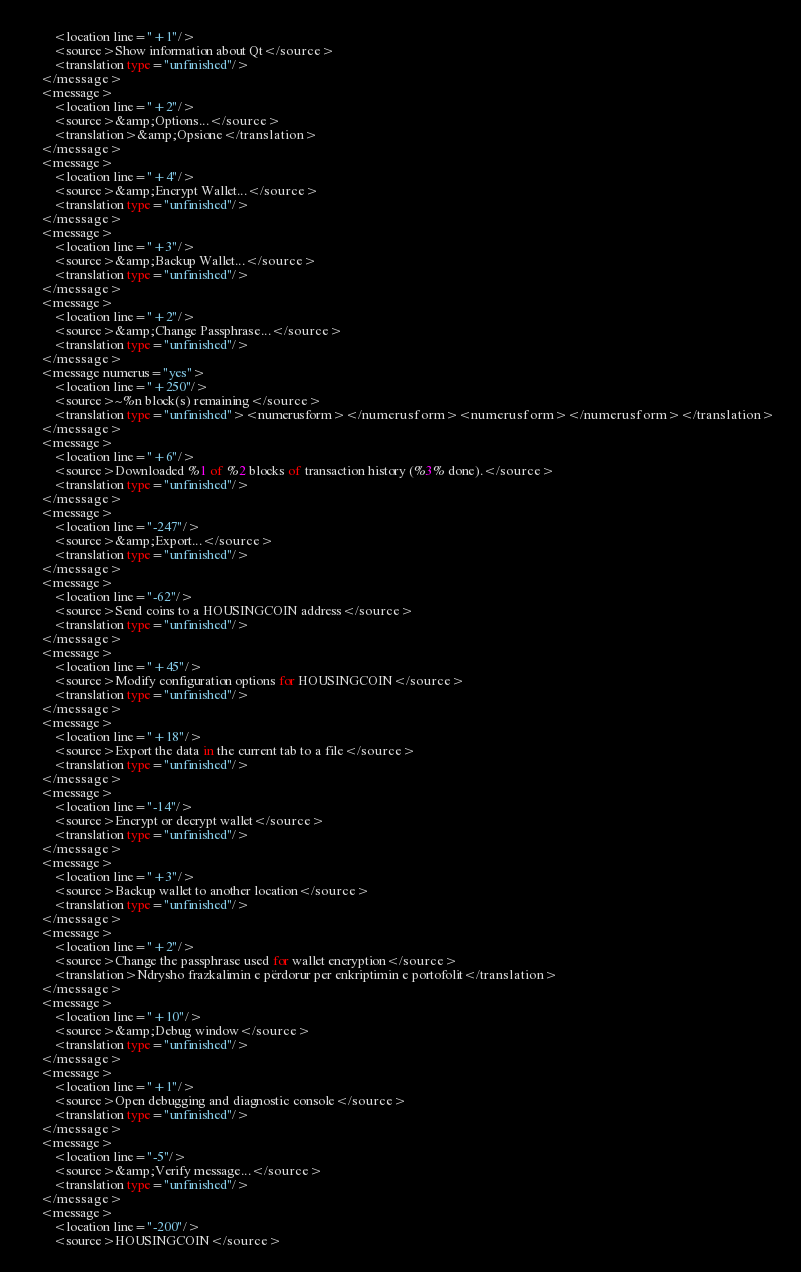Convert code to text. <code><loc_0><loc_0><loc_500><loc_500><_TypeScript_>        <location line="+1"/>
        <source>Show information about Qt</source>
        <translation type="unfinished"/>
    </message>
    <message>
        <location line="+2"/>
        <source>&amp;Options...</source>
        <translation>&amp;Opsione</translation>
    </message>
    <message>
        <location line="+4"/>
        <source>&amp;Encrypt Wallet...</source>
        <translation type="unfinished"/>
    </message>
    <message>
        <location line="+3"/>
        <source>&amp;Backup Wallet...</source>
        <translation type="unfinished"/>
    </message>
    <message>
        <location line="+2"/>
        <source>&amp;Change Passphrase...</source>
        <translation type="unfinished"/>
    </message>
    <message numerus="yes">
        <location line="+250"/>
        <source>~%n block(s) remaining</source>
        <translation type="unfinished"><numerusform></numerusform><numerusform></numerusform></translation>
    </message>
    <message>
        <location line="+6"/>
        <source>Downloaded %1 of %2 blocks of transaction history (%3% done).</source>
        <translation type="unfinished"/>
    </message>
    <message>
        <location line="-247"/>
        <source>&amp;Export...</source>
        <translation type="unfinished"/>
    </message>
    <message>
        <location line="-62"/>
        <source>Send coins to a HOUSINGCOIN address</source>
        <translation type="unfinished"/>
    </message>
    <message>
        <location line="+45"/>
        <source>Modify configuration options for HOUSINGCOIN</source>
        <translation type="unfinished"/>
    </message>
    <message>
        <location line="+18"/>
        <source>Export the data in the current tab to a file</source>
        <translation type="unfinished"/>
    </message>
    <message>
        <location line="-14"/>
        <source>Encrypt or decrypt wallet</source>
        <translation type="unfinished"/>
    </message>
    <message>
        <location line="+3"/>
        <source>Backup wallet to another location</source>
        <translation type="unfinished"/>
    </message>
    <message>
        <location line="+2"/>
        <source>Change the passphrase used for wallet encryption</source>
        <translation>Ndrysho frazkalimin e përdorur per enkriptimin e portofolit</translation>
    </message>
    <message>
        <location line="+10"/>
        <source>&amp;Debug window</source>
        <translation type="unfinished"/>
    </message>
    <message>
        <location line="+1"/>
        <source>Open debugging and diagnostic console</source>
        <translation type="unfinished"/>
    </message>
    <message>
        <location line="-5"/>
        <source>&amp;Verify message...</source>
        <translation type="unfinished"/>
    </message>
    <message>
        <location line="-200"/>
        <source>HOUSINGCOIN</source></code> 